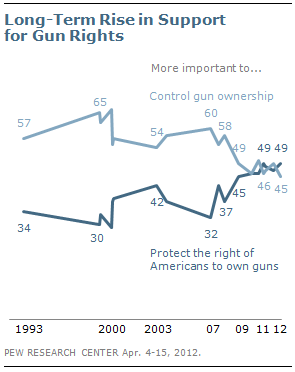List a handful of essential elements in this visual. The minimum value of the navy blue line is 30. The highest value of light blue graph is 65. 